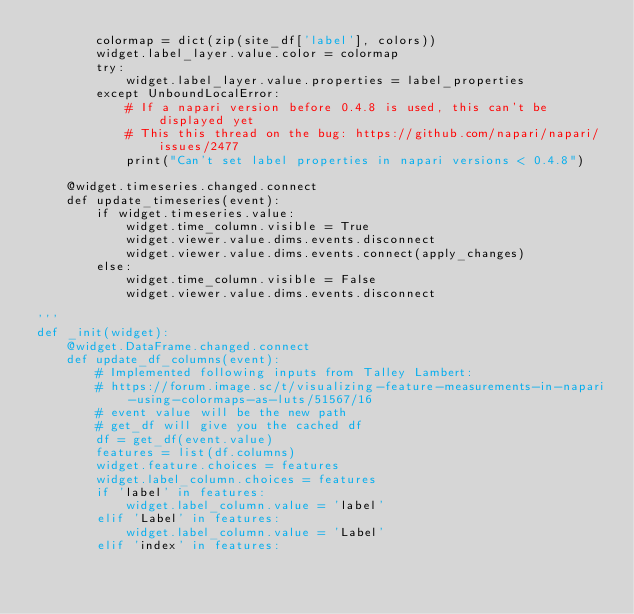<code> <loc_0><loc_0><loc_500><loc_500><_Python_>        colormap = dict(zip(site_df['label'], colors))
        widget.label_layer.value.color = colormap
        try:
            widget.label_layer.value.properties = label_properties
        except UnboundLocalError:
            # If a napari version before 0.4.8 is used, this can't be displayed yet
            # This this thread on the bug: https://github.com/napari/napari/issues/2477
            print("Can't set label properties in napari versions < 0.4.8")
            
    @widget.timeseries.changed.connect
    def update_timeseries(event):
        if widget.timeseries.value:
            widget.time_column.visible = True
            widget.viewer.value.dims.events.disconnect
            widget.viewer.value.dims.events.connect(apply_changes)
        else:
            widget.time_column.visible = False
            widget.viewer.value.dims.events.disconnect

'''
def _init(widget):
    @widget.DataFrame.changed.connect
    def update_df_columns(event):
        # Implemented following inputs from Talley Lambert:
        # https://forum.image.sc/t/visualizing-feature-measurements-in-napari-using-colormaps-as-luts/51567/16
        # event value will be the new path
        # get_df will give you the cached df
        df = get_df(event.value)
        features = list(df.columns)
        widget.feature.choices = features
        widget.label_column.choices = features
        if 'label' in features:
            widget.label_column.value = 'label'
        elif 'Label' in features:
            widget.label_column.value = 'Label'
        elif 'index' in features:</code> 